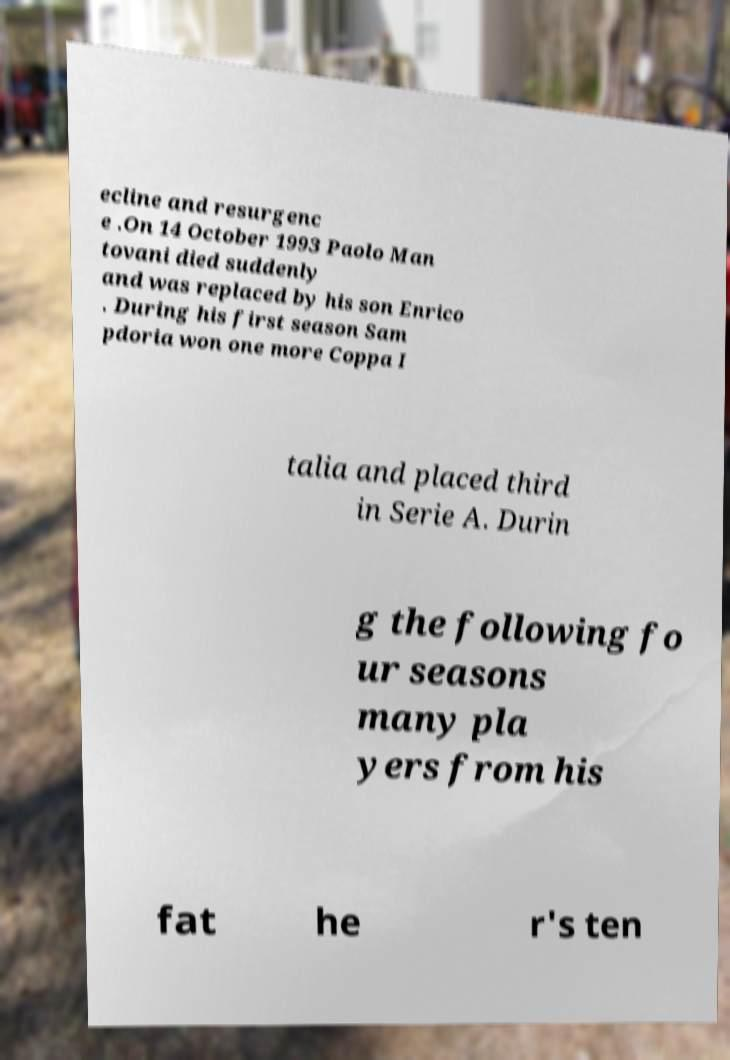Please read and relay the text visible in this image. What does it say? ecline and resurgenc e .On 14 October 1993 Paolo Man tovani died suddenly and was replaced by his son Enrico . During his first season Sam pdoria won one more Coppa I talia and placed third in Serie A. Durin g the following fo ur seasons many pla yers from his fat he r's ten 